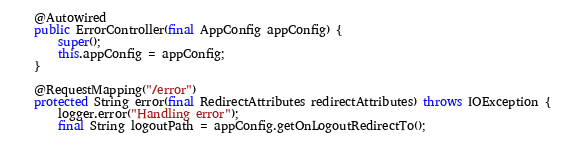Convert code to text. <code><loc_0><loc_0><loc_500><loc_500><_Java_>
    @Autowired
    public ErrorController(final AppConfig appConfig) {
        super();
        this.appConfig = appConfig;
    }

    @RequestMapping("/error")
    protected String error(final RedirectAttributes redirectAttributes) throws IOException {
        logger.error("Handling error");
        final String logoutPath = appConfig.getOnLogoutRedirectTo();</code> 